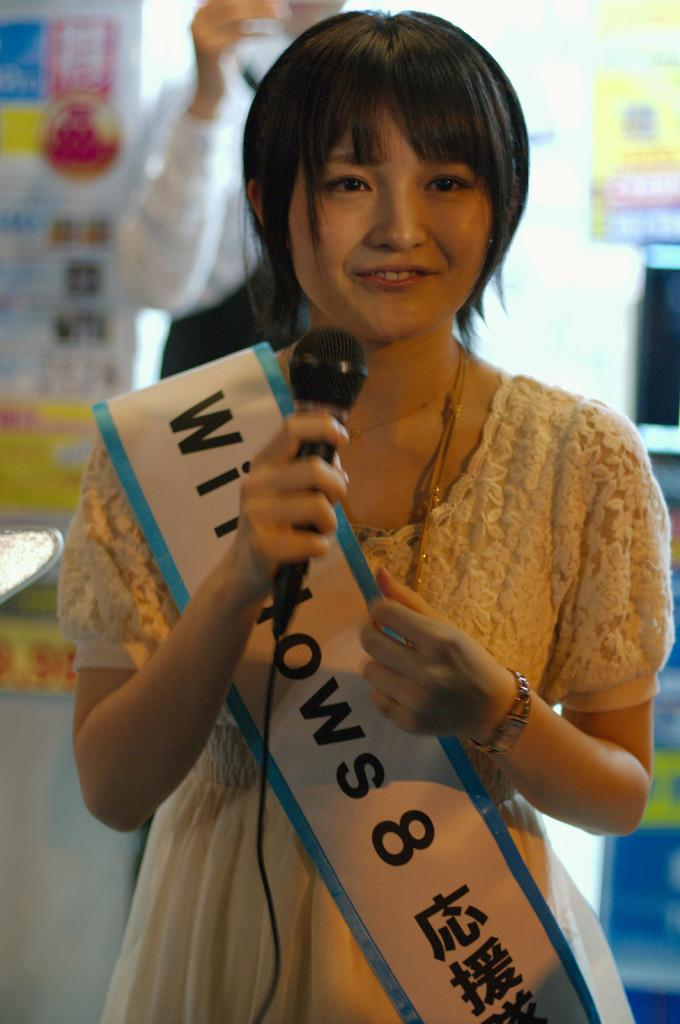Who is the main subject in the image? There is a woman in the image. What is the woman doing in the image? The woman is standing in the image. What object is the woman holding in her hand? The woman is holding a microphone in her hand. What type of plane is visible in the image? There is no plane present in the image; it features a woman holding a microphone. How is the woman using the needle in the image? There is no needle present in the image; the woman is holding a microphone. 